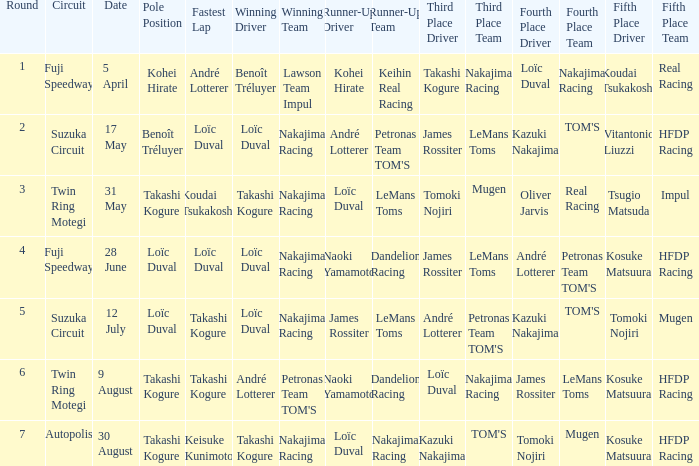Who was the driver for the winning team Lawson Team Impul? Benoît Tréluyer. 